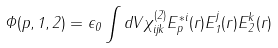<formula> <loc_0><loc_0><loc_500><loc_500>\Phi ( p , 1 , 2 ) = \epsilon _ { 0 } \int d V \chi ^ { ( 2 ) } _ { i j k } E ^ { * i } _ { p } ( r ) E ^ { j } _ { 1 } ( r ) E ^ { k } _ { 2 } ( r )</formula> 